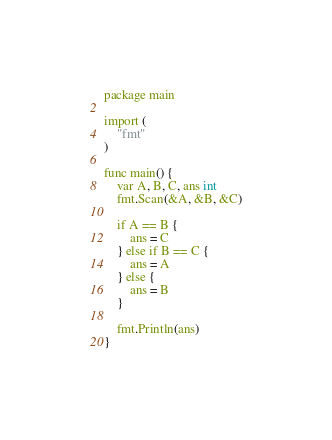Convert code to text. <code><loc_0><loc_0><loc_500><loc_500><_Go_>package main

import (
	"fmt"
)

func main() {
	var A, B, C, ans int
	fmt.Scan(&A, &B, &C)
	
	if A == B {
		ans = C
	} else if B == C {
		ans = A
	} else {
		ans = B
	}

	fmt.Println(ans)
}
</code> 